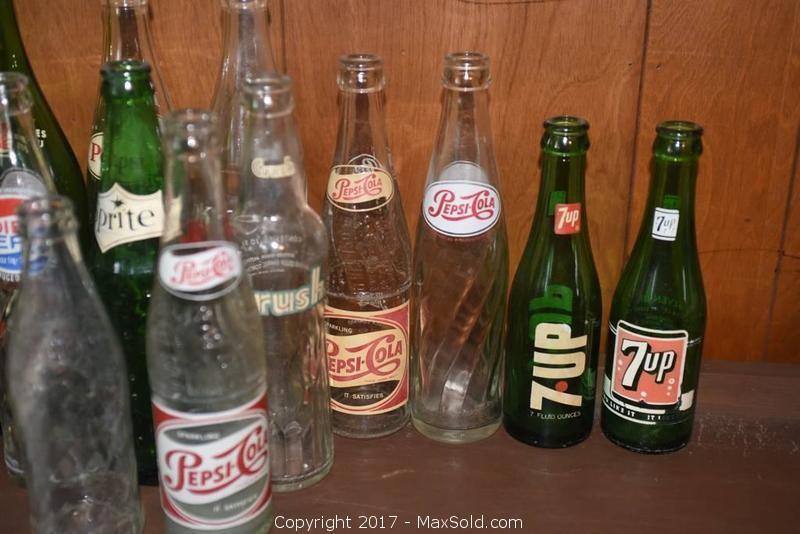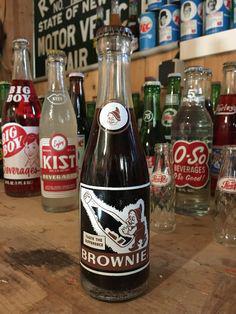The first image is the image on the left, the second image is the image on the right. Examine the images to the left and right. Is the description "All the bottles in these images are unopened and full of a beverage." accurate? Answer yes or no. No. The first image is the image on the left, the second image is the image on the right. Given the left and right images, does the statement "There are empty bottles sitting on a shelf." hold true? Answer yes or no. Yes. 